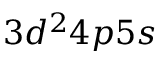Convert formula to latex. <formula><loc_0><loc_0><loc_500><loc_500>3 d ^ { 2 } 4 p 5 s</formula> 